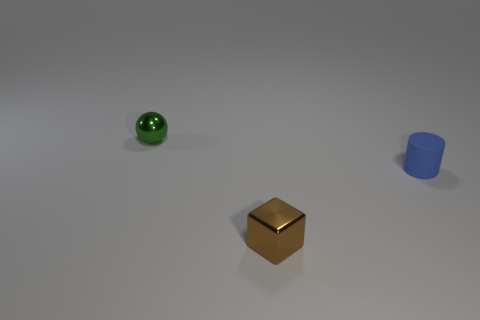Are there any other things that are the same shape as the small blue rubber object?
Your answer should be compact. No. How many tiny cylinders are the same color as the cube?
Offer a terse response. 0. Are there any large gray matte spheres?
Your answer should be very brief. No. There is a brown object; does it have the same shape as the small metallic object behind the brown block?
Give a very brief answer. No. What color is the small shiny object that is on the right side of the tiny metallic object that is behind the shiny object right of the green shiny ball?
Ensure brevity in your answer.  Brown. Are there any small blue cylinders behind the small ball?
Ensure brevity in your answer.  No. Are there any cubes that have the same material as the green ball?
Your answer should be compact. Yes. The rubber cylinder is what color?
Give a very brief answer. Blue. Does the metal thing that is in front of the blue thing have the same shape as the small rubber thing?
Your response must be concise. No. The metal object that is to the left of the metal thing right of the tiny thing behind the blue thing is what shape?
Keep it short and to the point. Sphere. 